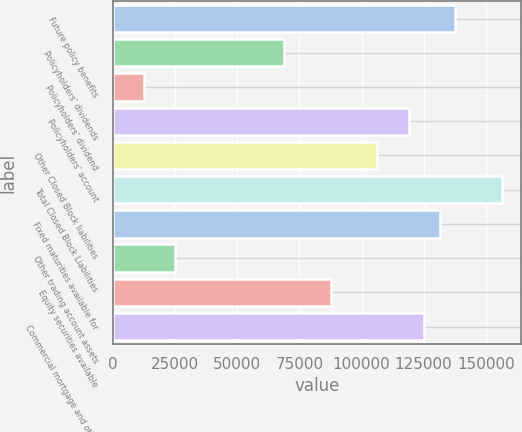Convert chart. <chart><loc_0><loc_0><loc_500><loc_500><bar_chart><fcel>Future policy benefits<fcel>Policyholders' dividends<fcel>Policyholders' dividend<fcel>Policyholders' account<fcel>Other Closed Block liabilities<fcel>Total Closed Block Liabilities<fcel>Fixed maturities available for<fcel>Other trading account assets<fcel>Equity securities available<fcel>Commercial mortgage and other<nl><fcel>137693<fcel>68846.8<fcel>12518<fcel>118917<fcel>106399<fcel>156469<fcel>131434<fcel>25035.5<fcel>87623<fcel>125176<nl></chart> 